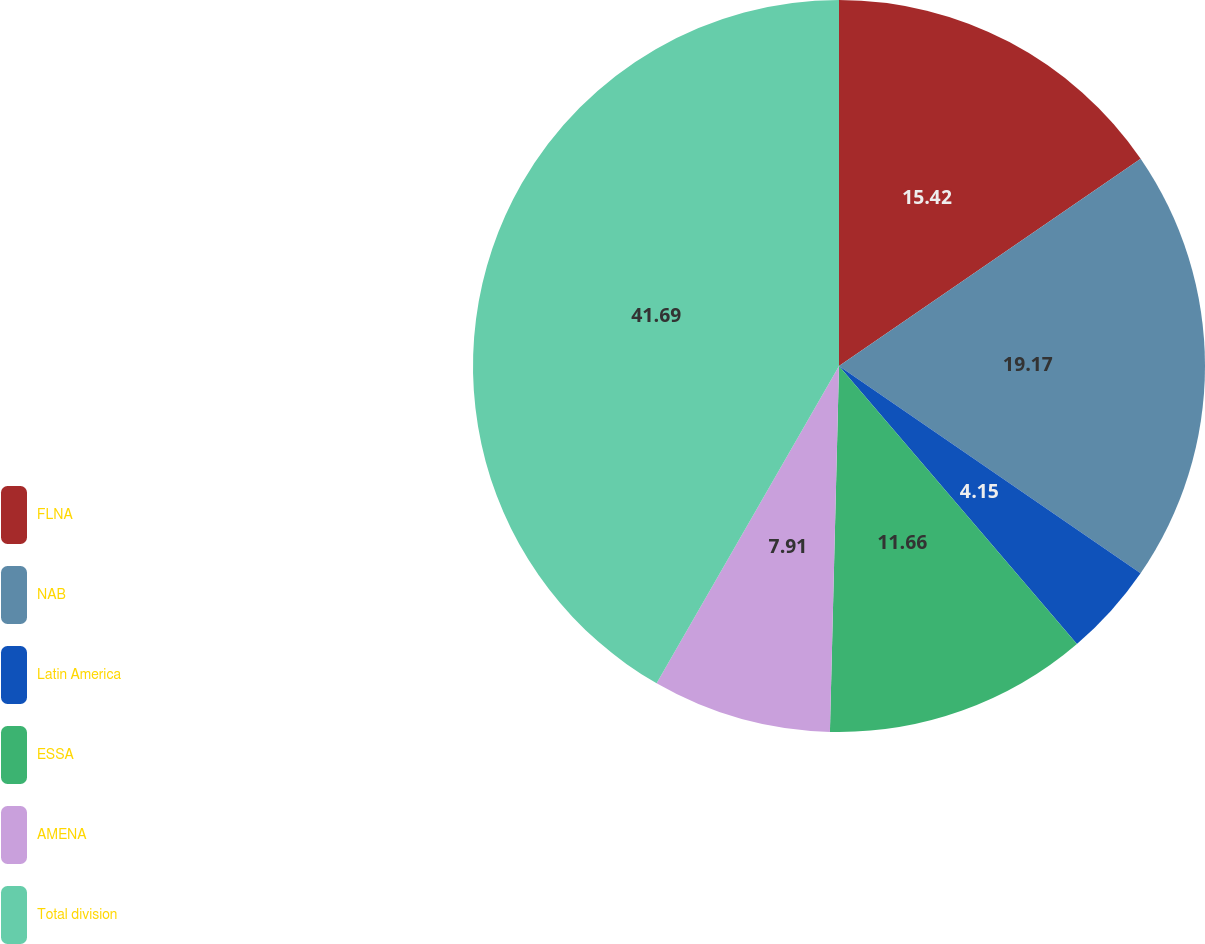Convert chart to OTSL. <chart><loc_0><loc_0><loc_500><loc_500><pie_chart><fcel>FLNA<fcel>NAB<fcel>Latin America<fcel>ESSA<fcel>AMENA<fcel>Total division<nl><fcel>15.42%<fcel>19.17%<fcel>4.15%<fcel>11.66%<fcel>7.91%<fcel>41.7%<nl></chart> 